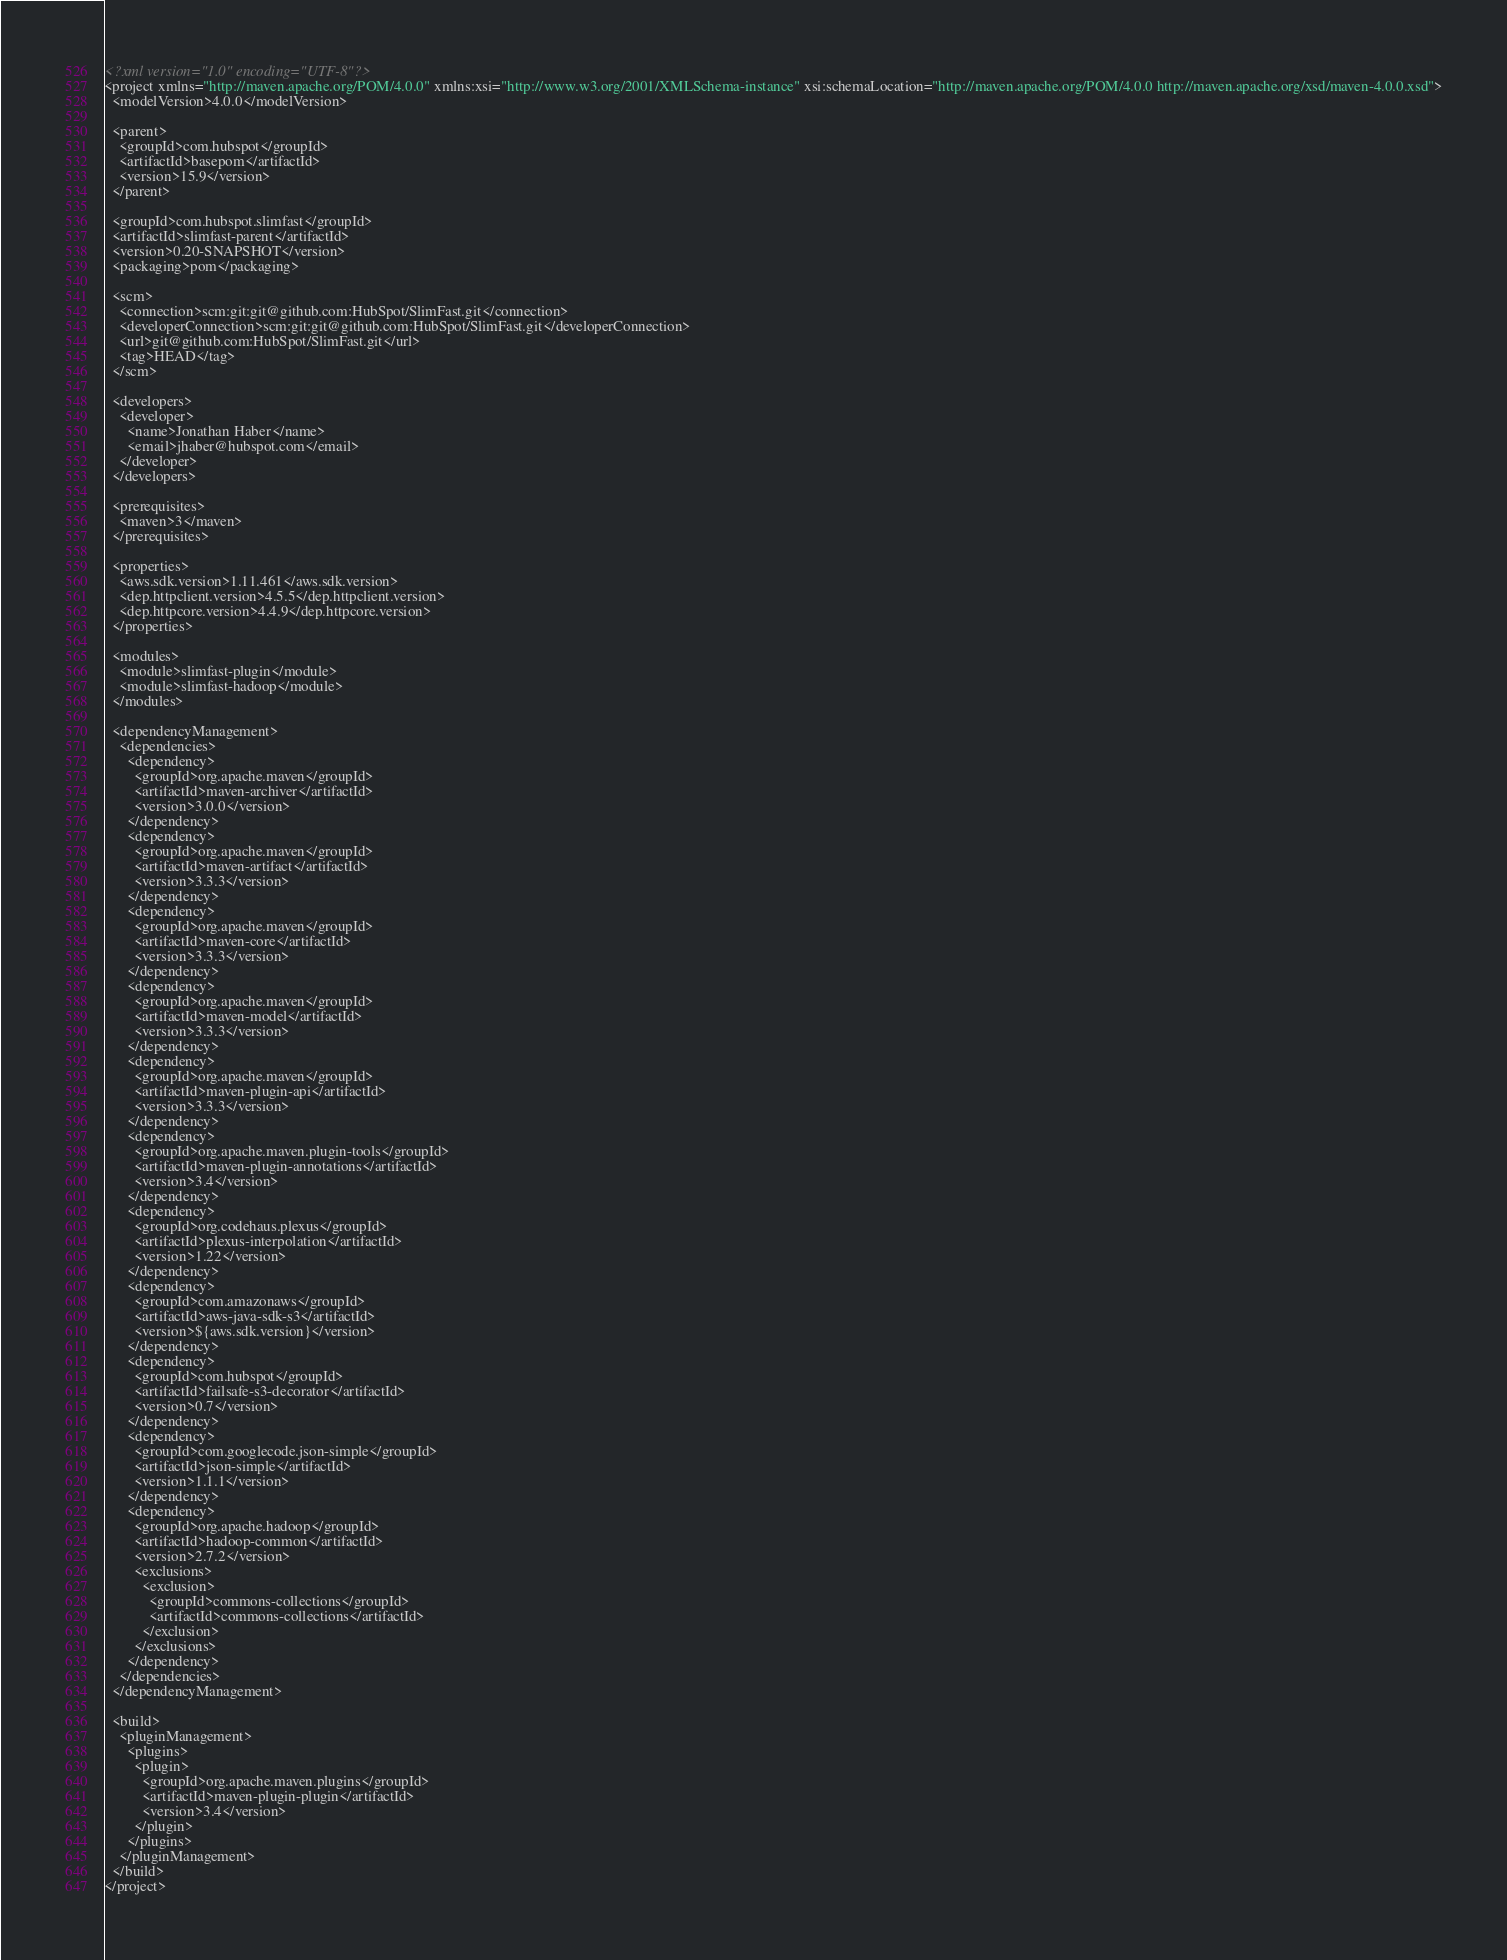Convert code to text. <code><loc_0><loc_0><loc_500><loc_500><_XML_><?xml version="1.0" encoding="UTF-8"?>
<project xmlns="http://maven.apache.org/POM/4.0.0" xmlns:xsi="http://www.w3.org/2001/XMLSchema-instance" xsi:schemaLocation="http://maven.apache.org/POM/4.0.0 http://maven.apache.org/xsd/maven-4.0.0.xsd">
  <modelVersion>4.0.0</modelVersion>

  <parent>
    <groupId>com.hubspot</groupId>
    <artifactId>basepom</artifactId>
    <version>15.9</version>
  </parent>

  <groupId>com.hubspot.slimfast</groupId>
  <artifactId>slimfast-parent</artifactId>
  <version>0.20-SNAPSHOT</version>
  <packaging>pom</packaging>

  <scm>
    <connection>scm:git:git@github.com:HubSpot/SlimFast.git</connection>
    <developerConnection>scm:git:git@github.com:HubSpot/SlimFast.git</developerConnection>
    <url>git@github.com:HubSpot/SlimFast.git</url>
    <tag>HEAD</tag>
  </scm>

  <developers>
    <developer>
      <name>Jonathan Haber</name>
      <email>jhaber@hubspot.com</email>
    </developer>
  </developers>

  <prerequisites>
    <maven>3</maven>
  </prerequisites>

  <properties>
    <aws.sdk.version>1.11.461</aws.sdk.version>
    <dep.httpclient.version>4.5.5</dep.httpclient.version>
    <dep.httpcore.version>4.4.9</dep.httpcore.version>
  </properties>

  <modules>
    <module>slimfast-plugin</module>
    <module>slimfast-hadoop</module>
  </modules>

  <dependencyManagement>
    <dependencies>
      <dependency>
        <groupId>org.apache.maven</groupId>
        <artifactId>maven-archiver</artifactId>
        <version>3.0.0</version>
      </dependency>
      <dependency>
        <groupId>org.apache.maven</groupId>
        <artifactId>maven-artifact</artifactId>
        <version>3.3.3</version>
      </dependency>
      <dependency>
        <groupId>org.apache.maven</groupId>
        <artifactId>maven-core</artifactId>
        <version>3.3.3</version>
      </dependency>
      <dependency>
        <groupId>org.apache.maven</groupId>
        <artifactId>maven-model</artifactId>
        <version>3.3.3</version>
      </dependency>
      <dependency>
        <groupId>org.apache.maven</groupId>
        <artifactId>maven-plugin-api</artifactId>
        <version>3.3.3</version>
      </dependency>
      <dependency>
        <groupId>org.apache.maven.plugin-tools</groupId>
        <artifactId>maven-plugin-annotations</artifactId>
        <version>3.4</version>
      </dependency>
      <dependency>
        <groupId>org.codehaus.plexus</groupId>
        <artifactId>plexus-interpolation</artifactId>
        <version>1.22</version>
      </dependency>
      <dependency>
        <groupId>com.amazonaws</groupId>
        <artifactId>aws-java-sdk-s3</artifactId>
        <version>${aws.sdk.version}</version>
      </dependency>
      <dependency>
        <groupId>com.hubspot</groupId>
        <artifactId>failsafe-s3-decorator</artifactId>
        <version>0.7</version>
      </dependency>
      <dependency>
        <groupId>com.googlecode.json-simple</groupId>
        <artifactId>json-simple</artifactId>
        <version>1.1.1</version>
      </dependency>
      <dependency>
        <groupId>org.apache.hadoop</groupId>
        <artifactId>hadoop-common</artifactId>
        <version>2.7.2</version>
        <exclusions>
          <exclusion>
            <groupId>commons-collections</groupId>
            <artifactId>commons-collections</artifactId>
          </exclusion>
        </exclusions>
      </dependency>
    </dependencies>
  </dependencyManagement>

  <build>
    <pluginManagement>
      <plugins>
        <plugin>
          <groupId>org.apache.maven.plugins</groupId>
          <artifactId>maven-plugin-plugin</artifactId>
          <version>3.4</version>
        </plugin>
      </plugins>
    </pluginManagement>
  </build>
</project>
</code> 